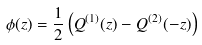<formula> <loc_0><loc_0><loc_500><loc_500>\phi ( z ) = \frac { 1 } { 2 } \left ( Q ^ { ( 1 ) } ( z ) - Q ^ { ( 2 ) } ( - z ) \right )</formula> 